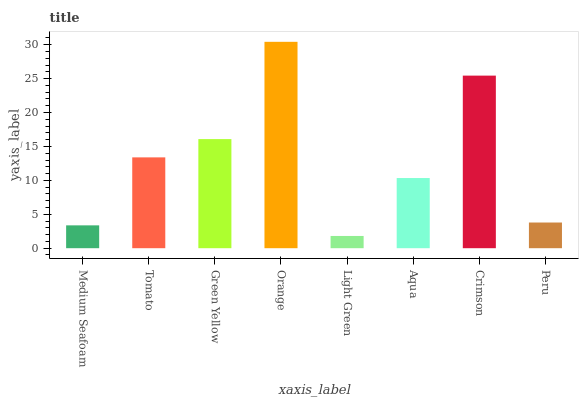Is Light Green the minimum?
Answer yes or no. Yes. Is Orange the maximum?
Answer yes or no. Yes. Is Tomato the minimum?
Answer yes or no. No. Is Tomato the maximum?
Answer yes or no. No. Is Tomato greater than Medium Seafoam?
Answer yes or no. Yes. Is Medium Seafoam less than Tomato?
Answer yes or no. Yes. Is Medium Seafoam greater than Tomato?
Answer yes or no. No. Is Tomato less than Medium Seafoam?
Answer yes or no. No. Is Tomato the high median?
Answer yes or no. Yes. Is Aqua the low median?
Answer yes or no. Yes. Is Crimson the high median?
Answer yes or no. No. Is Medium Seafoam the low median?
Answer yes or no. No. 